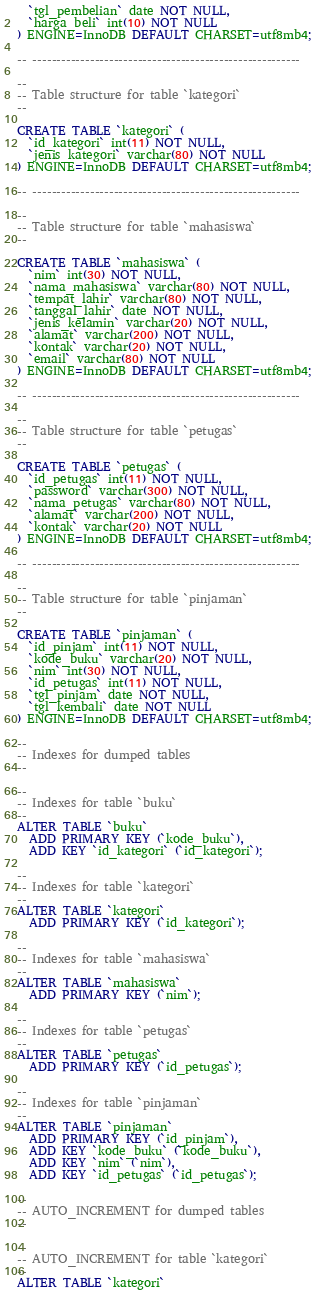Convert code to text. <code><loc_0><loc_0><loc_500><loc_500><_SQL_>  `tgl_pembelian` date NOT NULL,
  `harga_beli` int(10) NOT NULL
) ENGINE=InnoDB DEFAULT CHARSET=utf8mb4;

-- --------------------------------------------------------

--
-- Table structure for table `kategori`
--

CREATE TABLE `kategori` (
  `id_kategori` int(11) NOT NULL,
  `jenis_kategori` varchar(80) NOT NULL
) ENGINE=InnoDB DEFAULT CHARSET=utf8mb4;

-- --------------------------------------------------------

--
-- Table structure for table `mahasiswa`
--

CREATE TABLE `mahasiswa` (
  `nim` int(30) NOT NULL,
  `nama_mahasiswa` varchar(80) NOT NULL,
  `tempat_lahir` varchar(80) NOT NULL,
  `tanggal_lahir` date NOT NULL,
  `jenis_kelamin` varchar(20) NOT NULL,
  `alamat` varchar(200) NOT NULL,
  `kontak` varchar(20) NOT NULL,
  `email` varchar(80) NOT NULL
) ENGINE=InnoDB DEFAULT CHARSET=utf8mb4;

-- --------------------------------------------------------

--
-- Table structure for table `petugas`
--

CREATE TABLE `petugas` (
  `id_petugas` int(11) NOT NULL,
  `password` varchar(300) NOT NULL,
  `nama_petugas` varchar(80) NOT NULL,
  `alamat` varchar(200) NOT NULL,
  `kontak` varchar(20) NOT NULL
) ENGINE=InnoDB DEFAULT CHARSET=utf8mb4;

-- --------------------------------------------------------

--
-- Table structure for table `pinjaman`
--

CREATE TABLE `pinjaman` (
  `id_pinjam` int(11) NOT NULL,
  `kode_buku` varchar(20) NOT NULL,
  `nim` int(30) NOT NULL,
  `id_petugas` int(11) NOT NULL,
  `tgl_pinjam` date NOT NULL,
  `tgl_kembali` date NOT NULL
) ENGINE=InnoDB DEFAULT CHARSET=utf8mb4;

--
-- Indexes for dumped tables
--

--
-- Indexes for table `buku`
--
ALTER TABLE `buku`
  ADD PRIMARY KEY (`kode_buku`),
  ADD KEY `id_kategori` (`id_kategori`);

--
-- Indexes for table `kategori`
--
ALTER TABLE `kategori`
  ADD PRIMARY KEY (`id_kategori`);

--
-- Indexes for table `mahasiswa`
--
ALTER TABLE `mahasiswa`
  ADD PRIMARY KEY (`nim`);

--
-- Indexes for table `petugas`
--
ALTER TABLE `petugas`
  ADD PRIMARY KEY (`id_petugas`);

--
-- Indexes for table `pinjaman`
--
ALTER TABLE `pinjaman`
  ADD PRIMARY KEY (`id_pinjam`),
  ADD KEY `kode_buku` (`kode_buku`),
  ADD KEY `nim` (`nim`),
  ADD KEY `id_petugas` (`id_petugas`);

--
-- AUTO_INCREMENT for dumped tables
--

--
-- AUTO_INCREMENT for table `kategori`
--
ALTER TABLE `kategori`</code> 